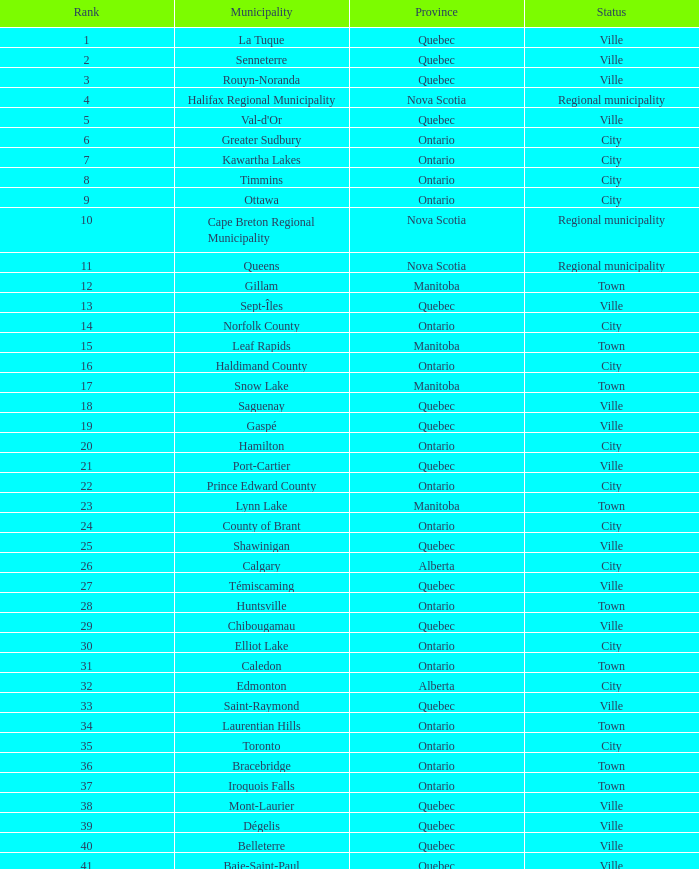Which municipality holds the 44th rank? Lakeshore. 